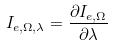<formula> <loc_0><loc_0><loc_500><loc_500>I _ { e , \Omega , \lambda } = \frac { \partial I _ { e , \Omega } } { \partial \lambda }</formula> 